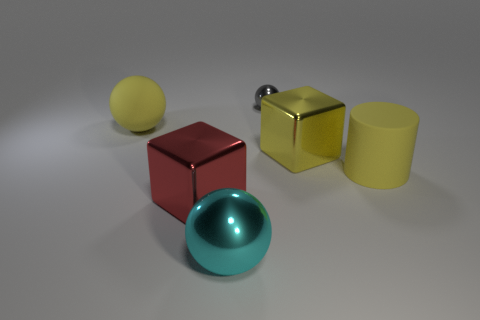Add 4 yellow matte cylinders. How many objects exist? 10 Subtract all cylinders. How many objects are left? 5 Subtract all yellow metal things. Subtract all big yellow matte spheres. How many objects are left? 4 Add 2 blocks. How many blocks are left? 4 Add 3 small purple shiny things. How many small purple shiny things exist? 3 Subtract 0 blue cubes. How many objects are left? 6 